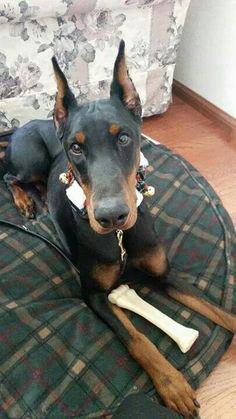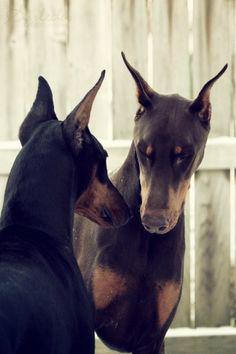The first image is the image on the left, the second image is the image on the right. Examine the images to the left and right. Is the description "There are exactly two dogs." accurate? Answer yes or no. No. 